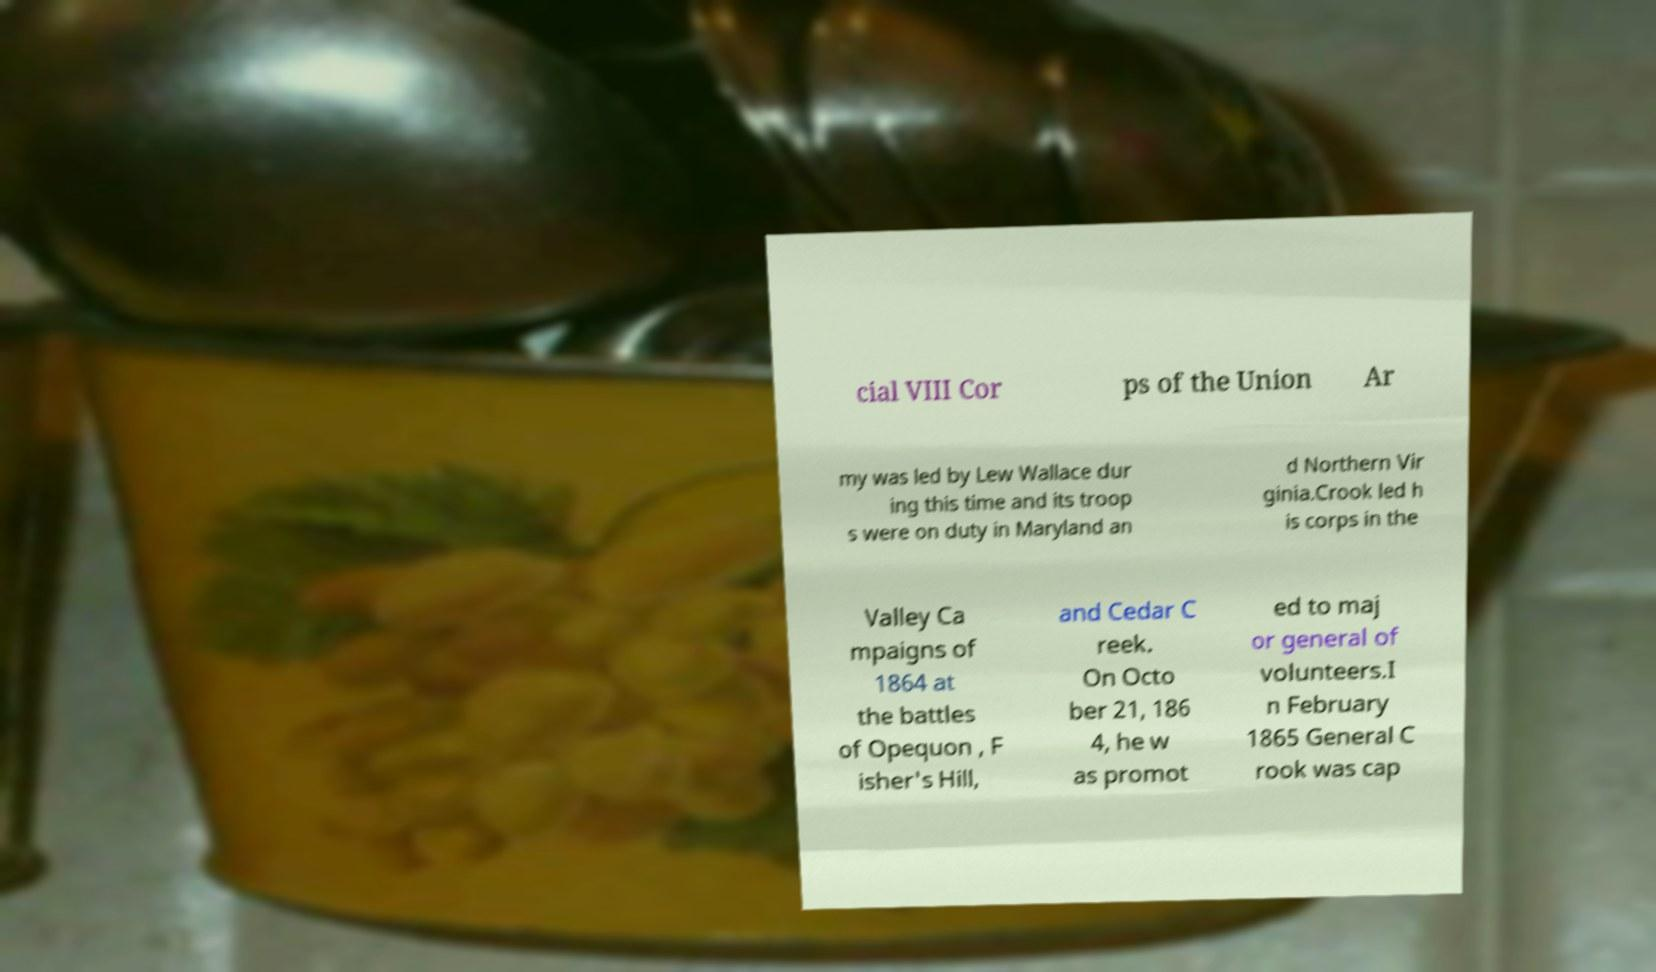Could you extract and type out the text from this image? cial VIII Cor ps of the Union Ar my was led by Lew Wallace dur ing this time and its troop s were on duty in Maryland an d Northern Vir ginia.Crook led h is corps in the Valley Ca mpaigns of 1864 at the battles of Opequon , F isher's Hill, and Cedar C reek. On Octo ber 21, 186 4, he w as promot ed to maj or general of volunteers.I n February 1865 General C rook was cap 